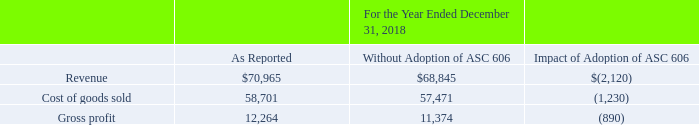3. REVENUE FROM CONTRACTS WITH CUSTOMERS
Revenues and related costs on construction contracts are recognized as the performance obligations are satisfied over time in accordance with ASC 606, Revenue from Contracts with Customers. Under ASC 606, revenue and associated profit, will be recognized as the customer obtains control of the goods and services promised in the contract (i.e., performance obligations). The cost of uninstalled materials or equipment will generally be excluded from the Company’s recognition of profit, unless specifically produced or manufactured for a project, because such costs are not considered to be a measure of progress.
The following tables summarize the impact of the adoption of ASC 606 on the Company’s condensed consolidated statement of operations for the year ended December 31, 2018 and the consolidated balance sheet as of December 31, 2018:
What is the  Revenue as reported? $70,965. When will cost of uninstalled materials or equipment be included in the recognition of profit? Specifically produced or manufactured for a project, because such costs are not considered to be a measure of progress. What does the table show? The impact of the adoption of asc 606 on the company’s condensed consolidated statement of operations for the year ended december 31, 2018 and the consolidated balance sheet as of december 31, 2018. What is the percentage change in revenue after the adoption of ASC 606?
Answer scale should be: percent. (70,965-68,845)/68,845
Answer: 3.08. What is the percentage change in the costs of goods sold after the adoption of ASC 606?
Answer scale should be: percent. (58,701-57,471)/57,471
Answer: 2.14. What is the gross profit ratio for the year ended December 31, 2018? 12,264/70,965
Answer: 0.17. 